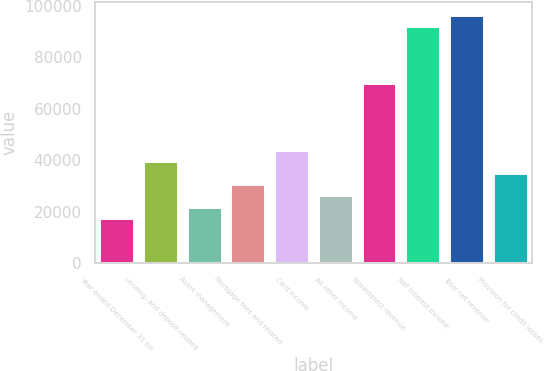Convert chart. <chart><loc_0><loc_0><loc_500><loc_500><bar_chart><fcel>Year ended December 31 (in<fcel>Lending- and deposit-related<fcel>Asset management<fcel>Mortgage fees and related<fcel>Card income<fcel>All other income<fcel>Noninterest revenue<fcel>Net interest income<fcel>Total net revenue<fcel>Provision for credit losses<nl><fcel>17538.8<fcel>39439.8<fcel>21919<fcel>30679.4<fcel>43820<fcel>26299.2<fcel>70101.2<fcel>92002.2<fcel>96382.4<fcel>35059.6<nl></chart> 